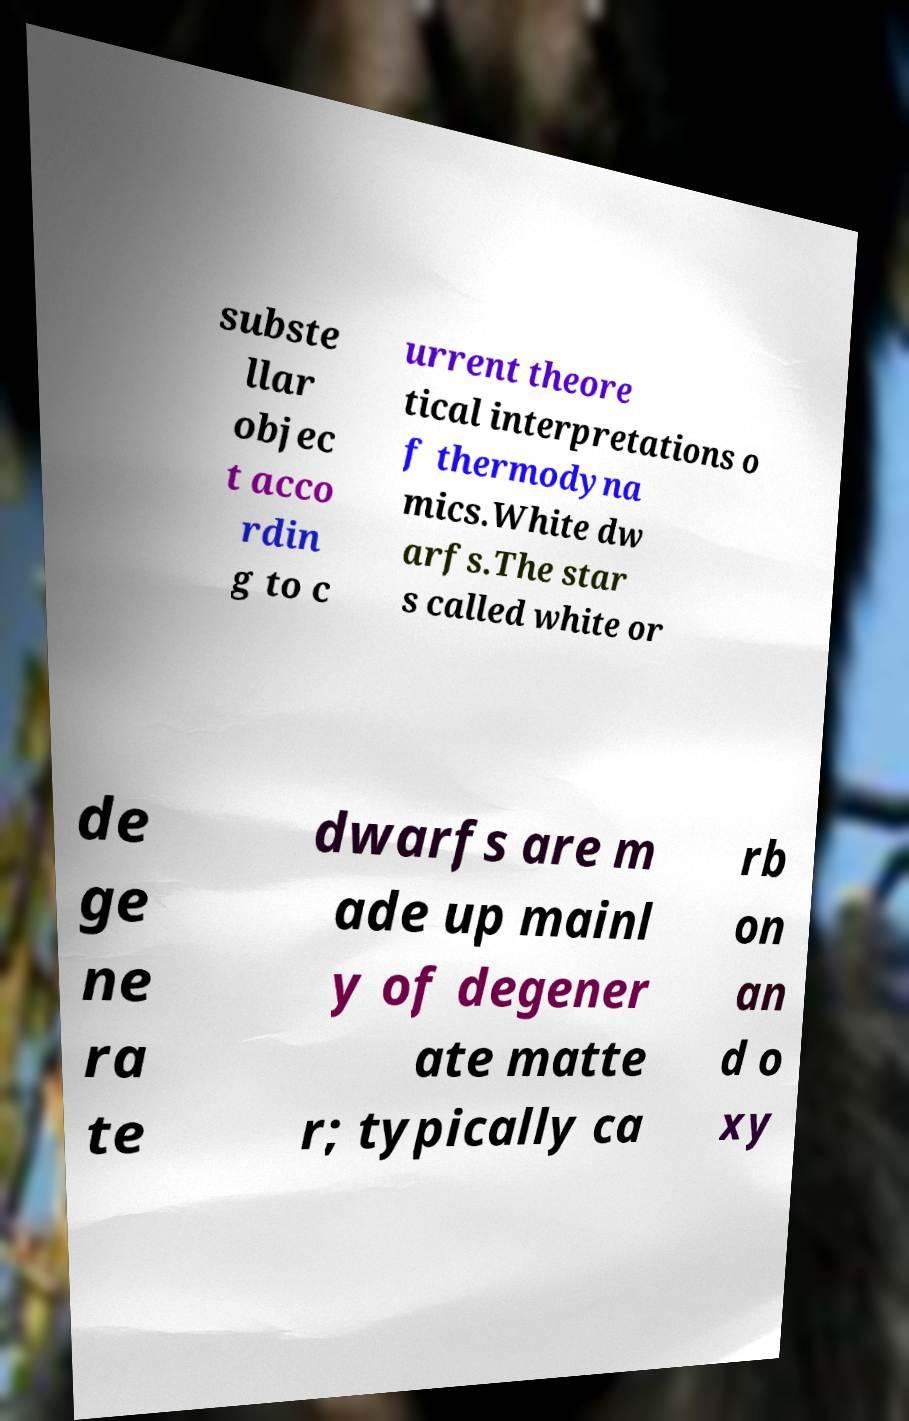Please identify and transcribe the text found in this image. subste llar objec t acco rdin g to c urrent theore tical interpretations o f thermodyna mics.White dw arfs.The star s called white or de ge ne ra te dwarfs are m ade up mainl y of degener ate matte r; typically ca rb on an d o xy 